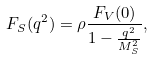<formula> <loc_0><loc_0><loc_500><loc_500>F _ { S } ( q ^ { 2 } ) = \rho \frac { F _ { V } ( 0 ) } { 1 - \frac { q ^ { 2 } } { M _ { S } ^ { 2 } } } ,</formula> 